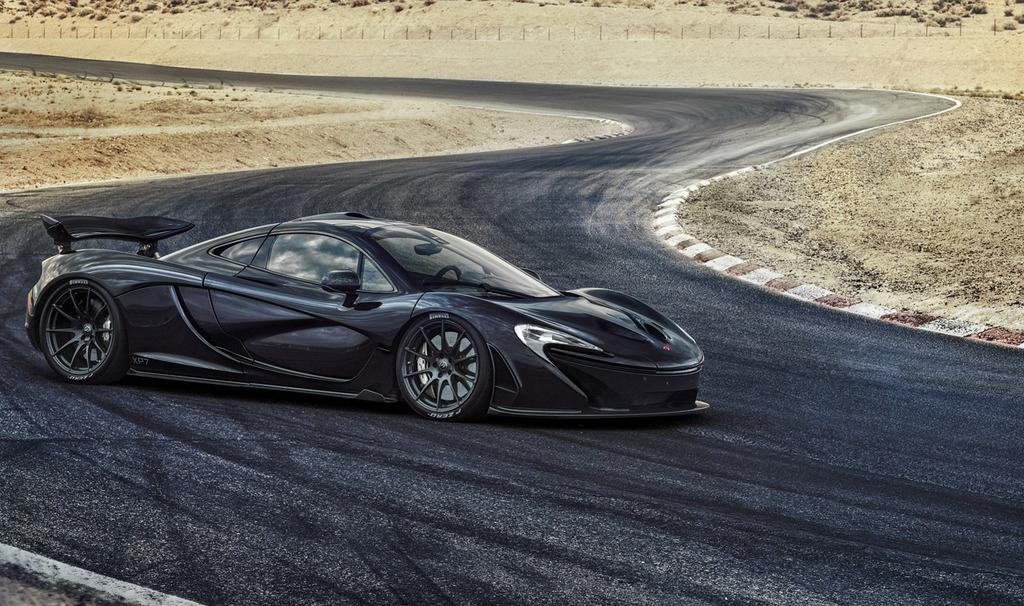What color is the car in the image? The car in the image is black. Where is the car located in the image? The car is parked on the road. What can be seen on both sides of the road? There is mud on both sides of the road. What objects are present on the ground behind the car? Small poles are present on the ground behind the car. What type of flesh can be seen on the car in the image? There is no flesh present on the car in the image; it is a black color car parked on the road. 